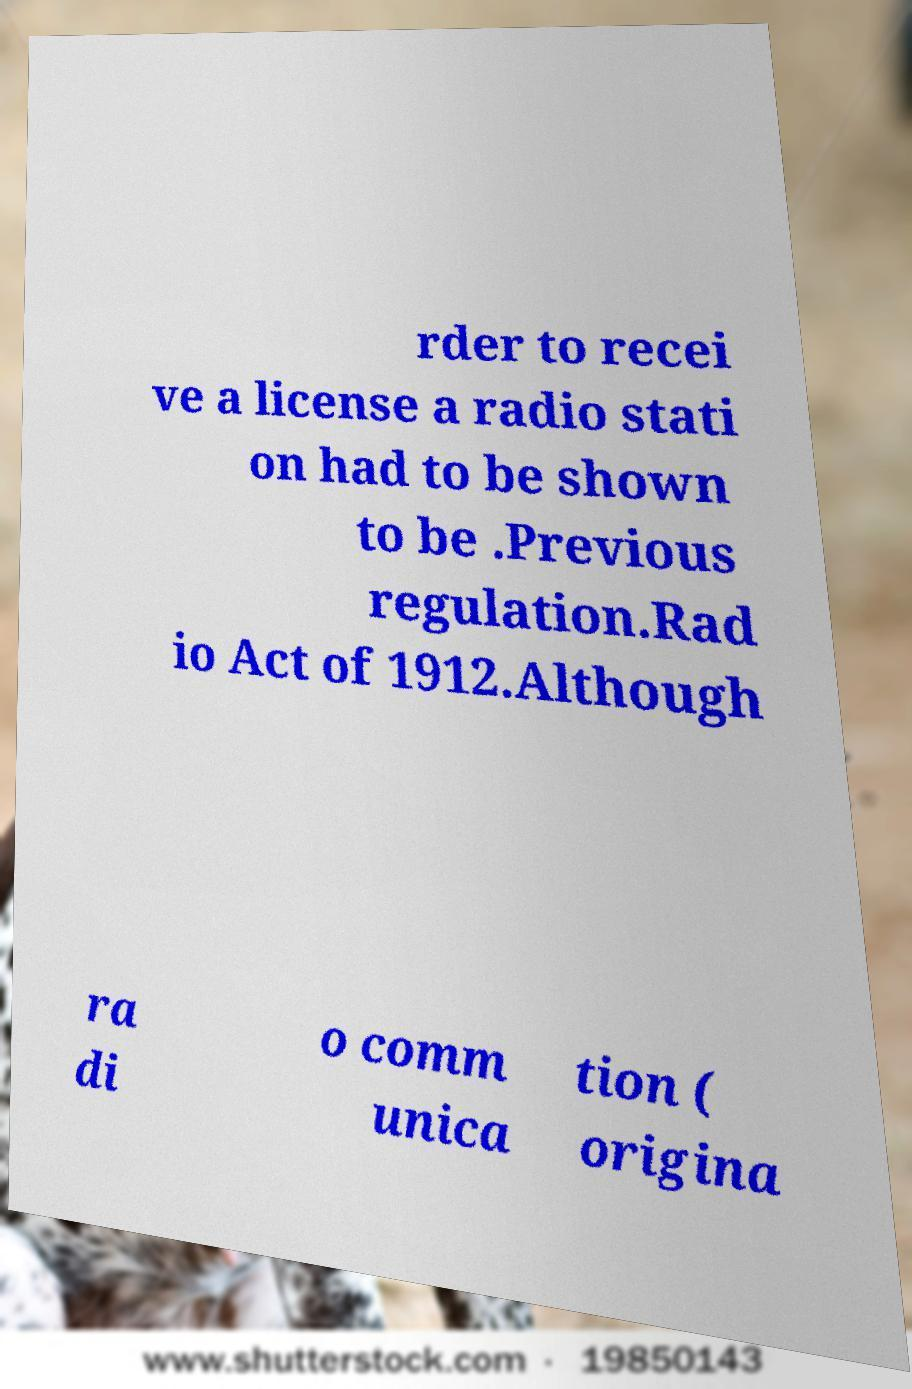Could you extract and type out the text from this image? rder to recei ve a license a radio stati on had to be shown to be .Previous regulation.Rad io Act of 1912.Although ra di o comm unica tion ( origina 